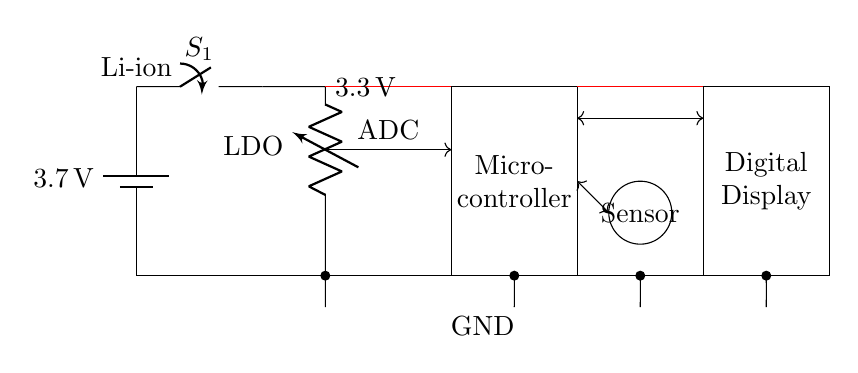What is the voltage of the battery? The circuit diagram indicates a battery labeled with a voltage of 3.7 volts. This information is directly readable from the battery component in the diagram.
Answer: 3.7 volts What component regulates the voltage in this circuit? The circuit shows a component labeled as LDO, which stands for Low Dropout Regulator. It is positioned between the battery and the microcontroller, indicating it regulates the voltage supplied to the circuit.
Answer: LDO How many main components are there in this circuit? The diagram includes five distinct components: a battery, a switch, a voltage regulator, a microcontroller, and a digital display. The sensor serves as an additional element linked to the microcontroller.
Answer: Five What type of display is used in this circuit? The diagram clearly shows a rectangular component labeled as Digital Display. This label indicates the type of display employed to communicate readings from the microcontroller.
Answer: Digital Display What is the function of the microcontroller in this circuit? The microcontroller, as depicted in the circuit, plays the role of processing the data received from the sensor. It acts as the brain of the system, interfacing between the sensor and the digital display.
Answer: Process data Which component connects the sensor to the microcontroller? In the diagram, the sensor is connected to the microcontroller via a two-way arrow, denoting bidirectional communication. This indicates the ability to send and receive signals between both components.
Answer: Sensor connection What is the purpose of the power switch labeled S1? The power switch labeled S1 allows for the control of power flow from the battery to the rest of the circuit. When open, it prevents current from flowing, and when closed, it allows the circuit to function.
Answer: Power control 